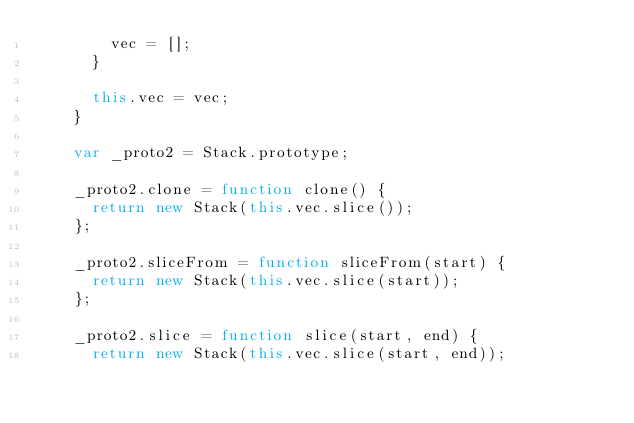<code> <loc_0><loc_0><loc_500><loc_500><_JavaScript_>        vec = [];
      }

      this.vec = vec;
    }

    var _proto2 = Stack.prototype;

    _proto2.clone = function clone() {
      return new Stack(this.vec.slice());
    };

    _proto2.sliceFrom = function sliceFrom(start) {
      return new Stack(this.vec.slice(start));
    };

    _proto2.slice = function slice(start, end) {
      return new Stack(this.vec.slice(start, end));</code> 